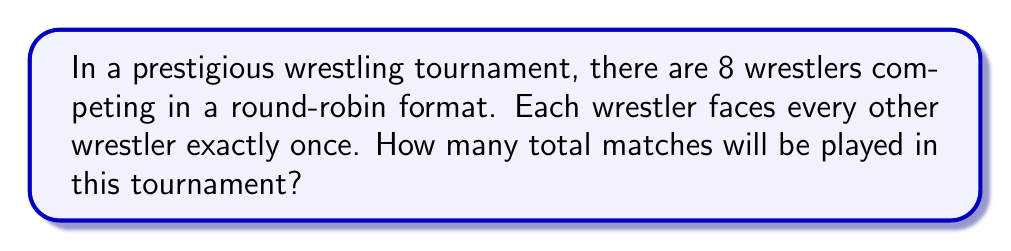Solve this math problem. Let's approach this step-by-step:

1) In a round-robin tournament, each participant plays against every other participant once.

2) With 8 wrestlers, each wrestler will face 7 others (everyone except themselves).

3) This might lead us to think the total number of matches is $8 \times 7 = 56$. However, this count is double the actual number because each match is counted twice (once for each wrestler involved).

4) To correct for this double-counting, we need to divide by 2.

5) The formula for the number of matches in a round-robin tournament with $n$ participants is:

   $$\frac{n(n-1)}{2}$$

6) In this case, $n = 8$, so we have:

   $$\frac{8(8-1)}{2} = \frac{8 \times 7}{2} = \frac{56}{2} = 28$$

7) We can also think of this combinatorially as choosing 2 wrestlers from 8 to compete in each match. This is denoted as $\binom{8}{2}$ or "8 choose 2", which is calculated the same way:

   $$\binom{8}{2} = \frac{8!}{2!(8-2)!} = \frac{8 \times 7}{2 \times 1} = 28$$

Therefore, there will be 28 matches in total in this round-robin tournament.
Answer: 28 matches 